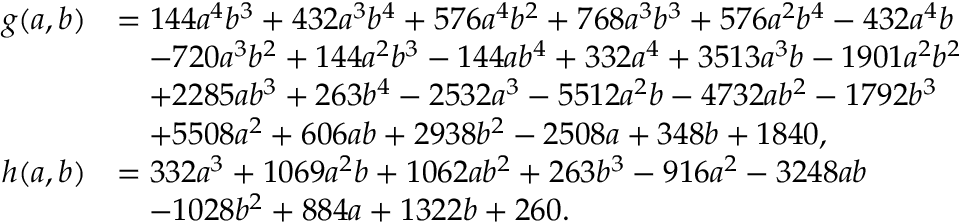Convert formula to latex. <formula><loc_0><loc_0><loc_500><loc_500>\begin{array} { r l } { g ( a , b ) } & { = 1 4 4 a ^ { 4 } b ^ { 3 } + 4 3 2 a ^ { 3 } b ^ { 4 } + 5 7 6 a ^ { 4 } b ^ { 2 } + 7 6 8 a ^ { 3 } b ^ { 3 } + 5 7 6 a ^ { 2 } b ^ { 4 } - 4 3 2 a ^ { 4 } b } \\ & { \quad - 7 2 0 a ^ { 3 } b ^ { 2 } + 1 4 4 a ^ { 2 } b ^ { 3 } - 1 4 4 a b ^ { 4 } + 3 3 2 a ^ { 4 } + 3 5 1 3 a ^ { 3 } b - 1 9 0 1 a ^ { 2 } b ^ { 2 } } \\ & { \quad + 2 2 8 5 a b ^ { 3 } + 2 6 3 b ^ { 4 } - 2 5 3 2 a ^ { 3 } - 5 5 1 2 a ^ { 2 } b - 4 7 3 2 a b ^ { 2 } - 1 7 9 2 b ^ { 3 } } \\ & { \quad + 5 5 0 8 a ^ { 2 } + 6 0 6 a b + 2 9 3 8 b ^ { 2 } - 2 5 0 8 a + 3 4 8 b + 1 8 4 0 , } \\ { h ( a , b ) } & { = 3 3 2 a ^ { 3 } + 1 0 6 9 a ^ { 2 } b + 1 0 6 2 a b ^ { 2 } + 2 6 3 b ^ { 3 } - 9 1 6 a ^ { 2 } - 3 2 4 8 a b } \\ & { \quad - 1 0 2 8 b ^ { 2 } + 8 8 4 a + 1 3 2 2 b + 2 6 0 . } \end{array}</formula> 